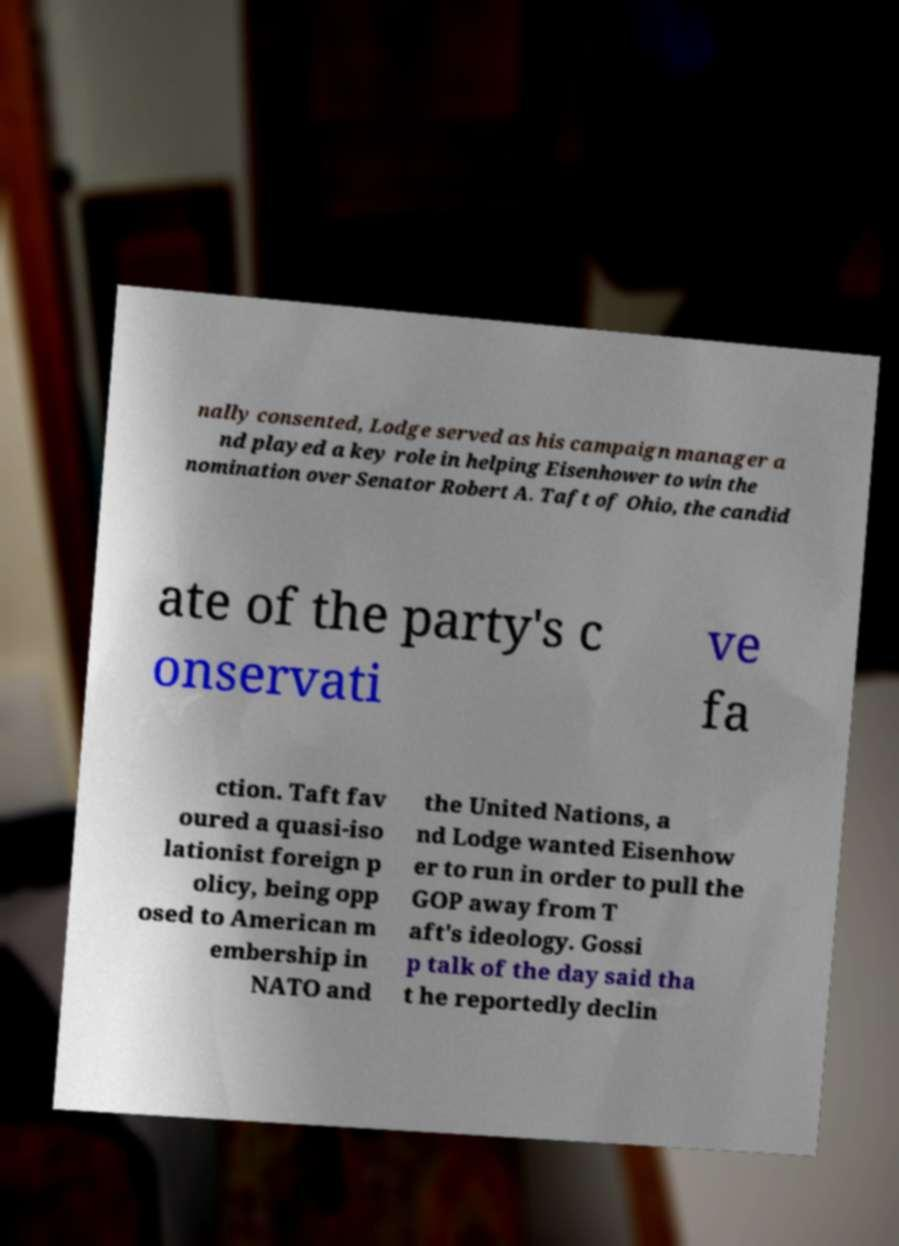What messages or text are displayed in this image? I need them in a readable, typed format. nally consented, Lodge served as his campaign manager a nd played a key role in helping Eisenhower to win the nomination over Senator Robert A. Taft of Ohio, the candid ate of the party's c onservati ve fa ction. Taft fav oured a quasi-iso lationist foreign p olicy, being opp osed to American m embership in NATO and the United Nations, a nd Lodge wanted Eisenhow er to run in order to pull the GOP away from T aft's ideology. Gossi p talk of the day said tha t he reportedly declin 